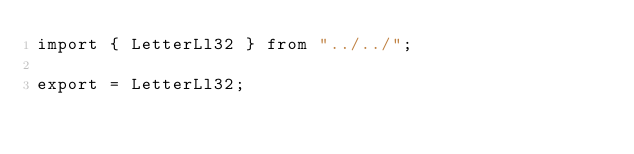Convert code to text. <code><loc_0><loc_0><loc_500><loc_500><_TypeScript_>import { LetterLl32 } from "../../";

export = LetterLl32;
</code> 